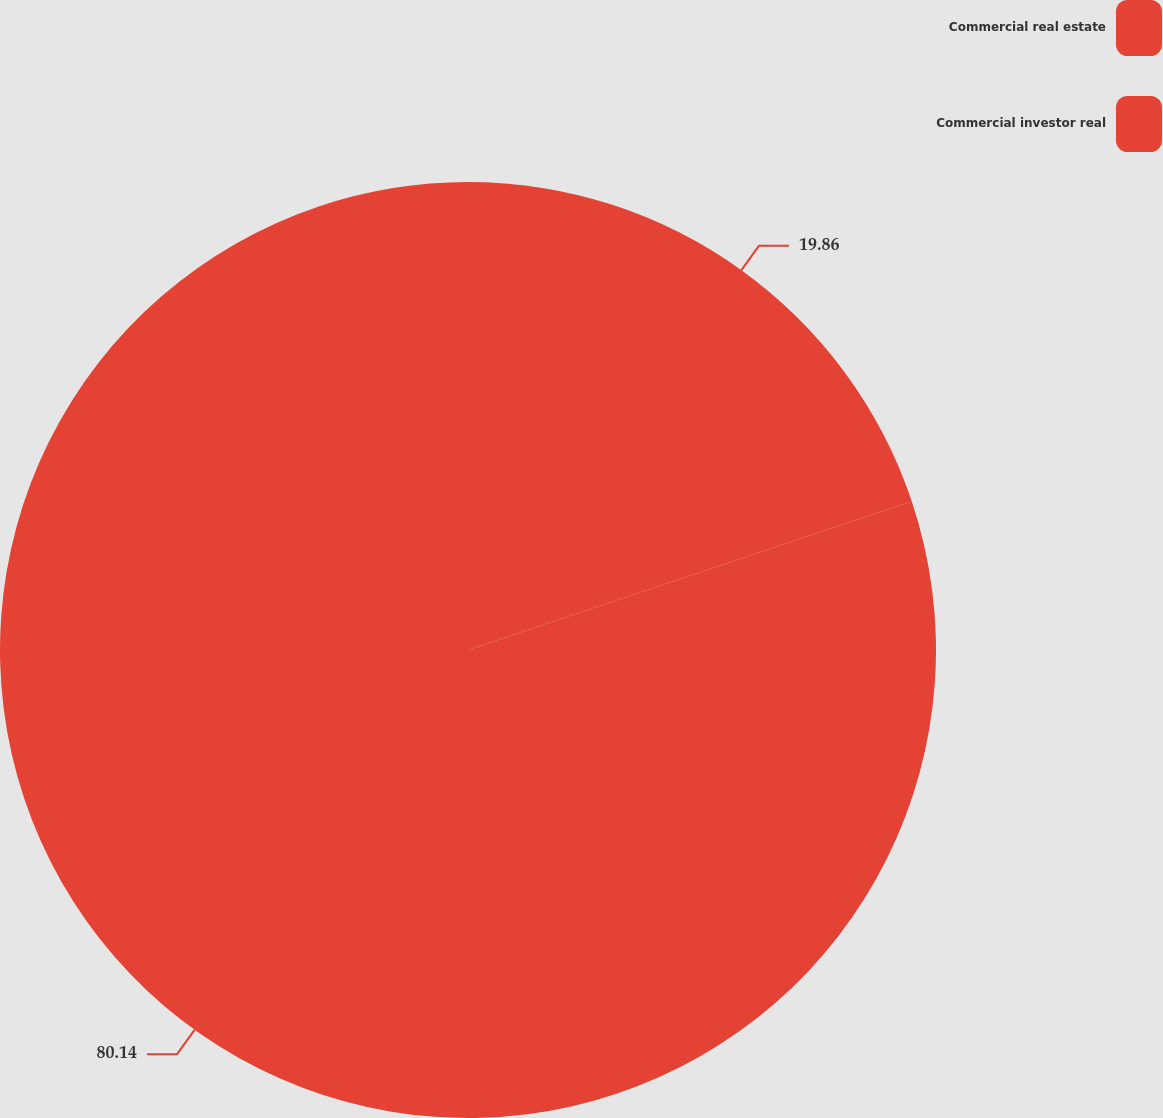Convert chart. <chart><loc_0><loc_0><loc_500><loc_500><pie_chart><fcel>Commercial real estate<fcel>Commercial investor real<nl><fcel>19.86%<fcel>80.14%<nl></chart> 